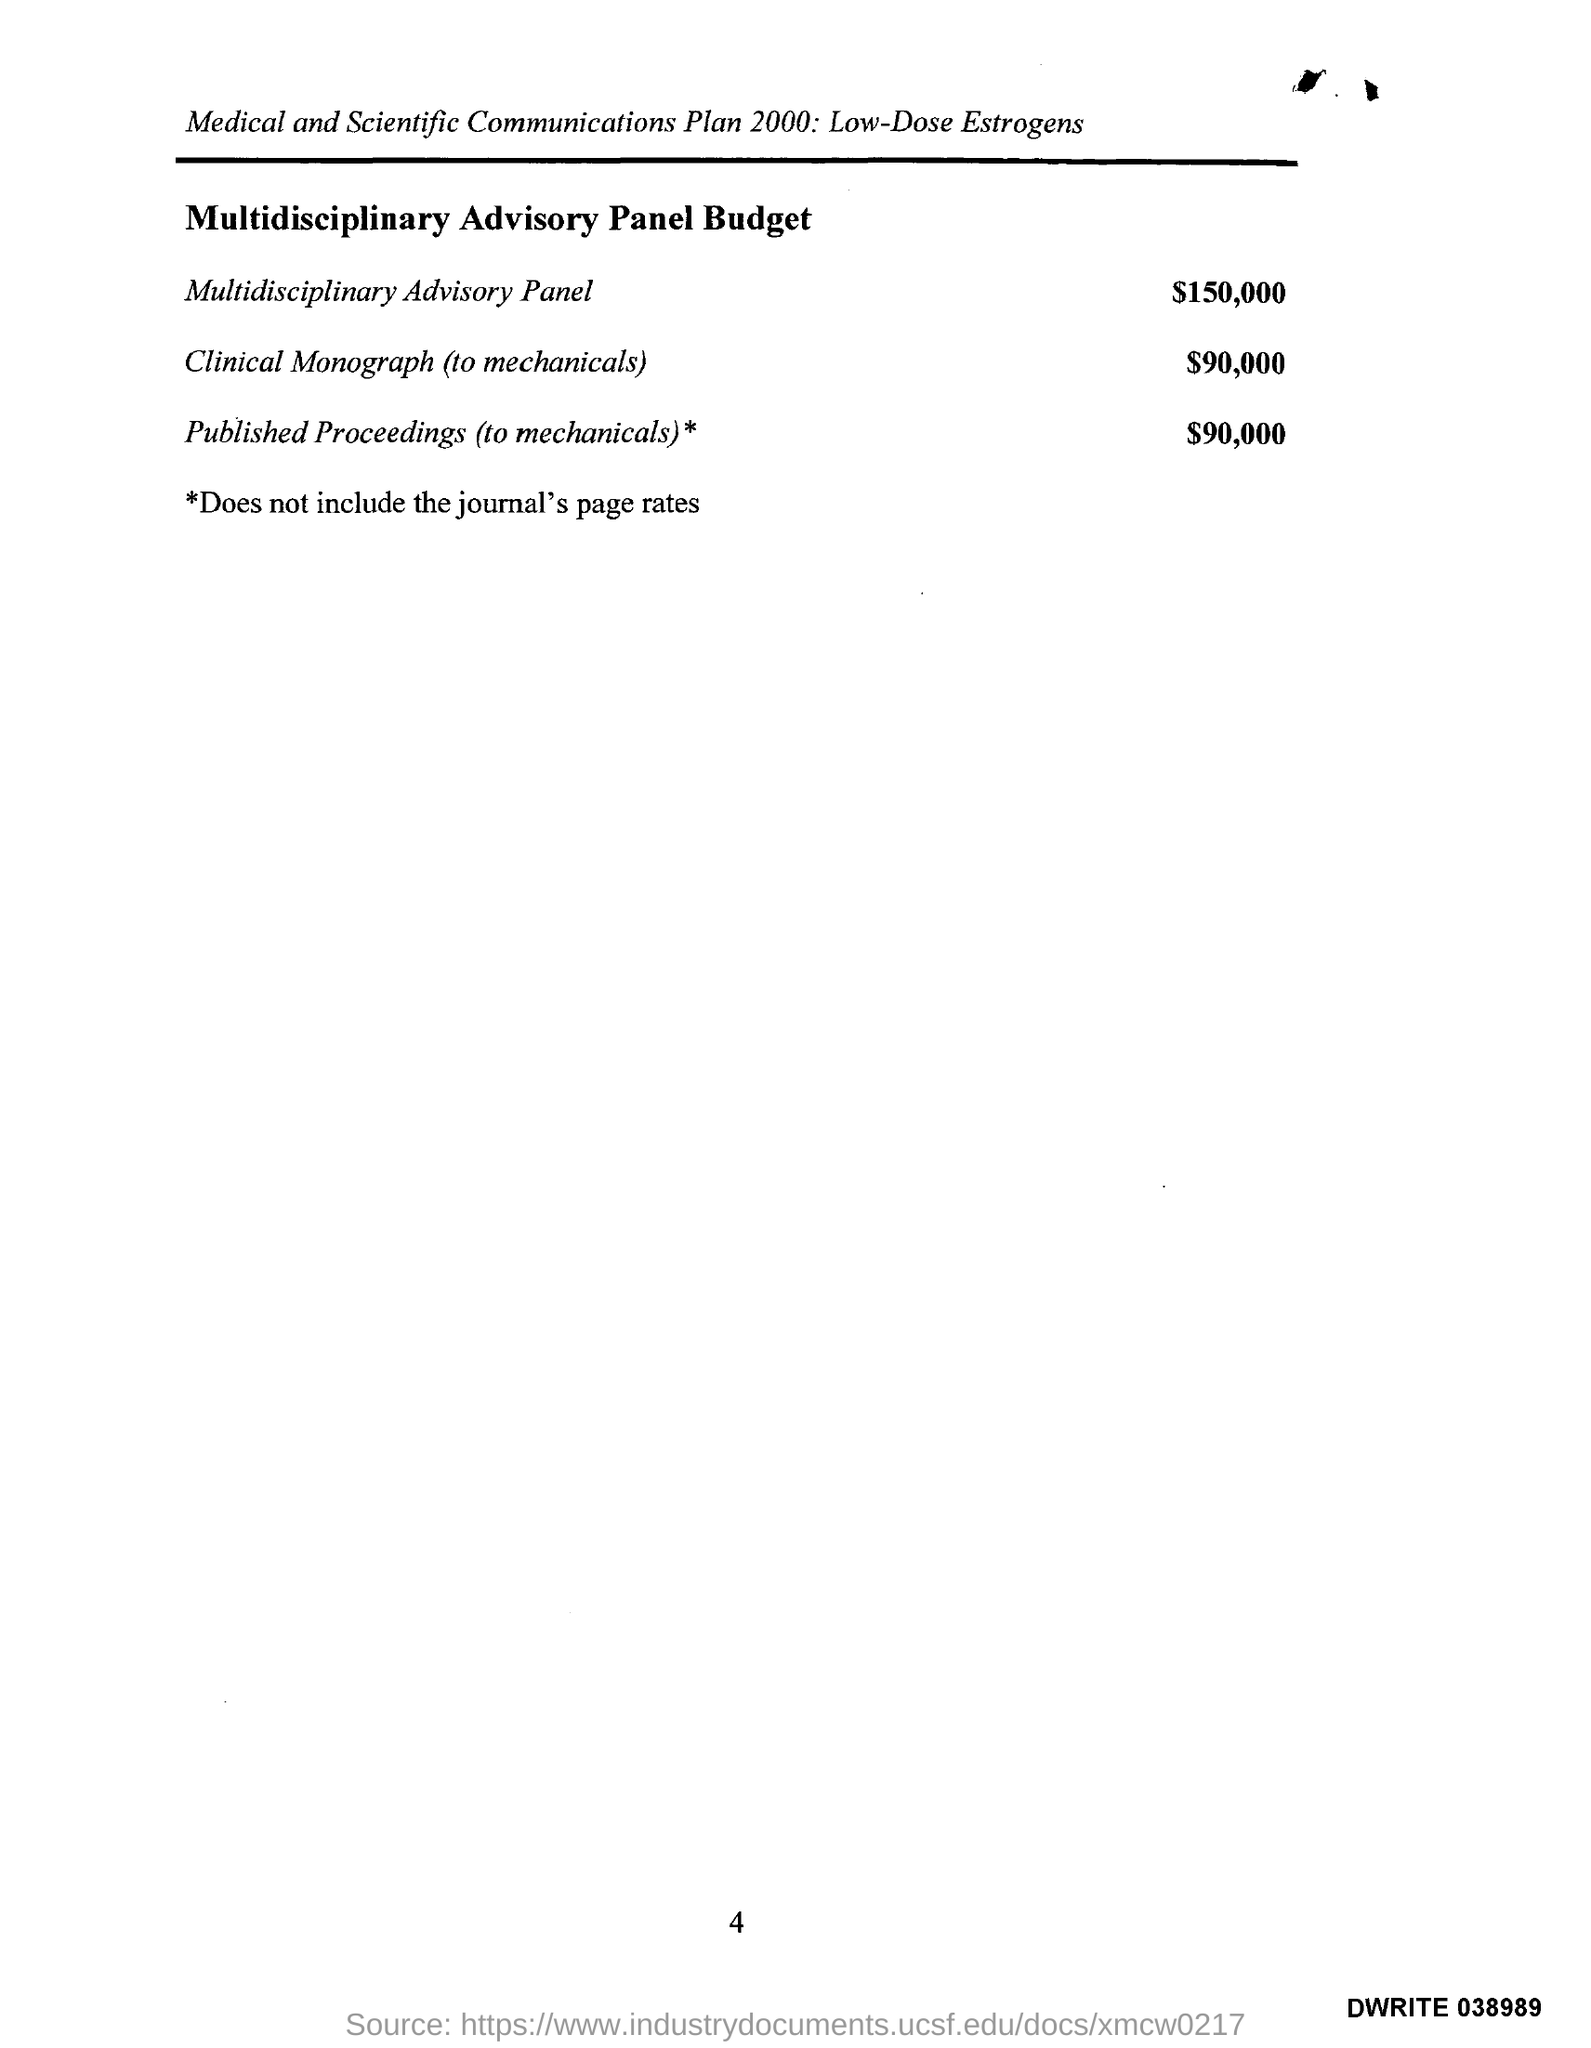What is the cost of multidisciplanary Advisory Panel?
Keep it short and to the point. $150,000. 